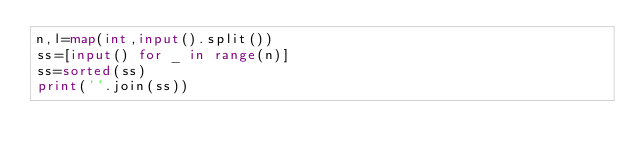Convert code to text. <code><loc_0><loc_0><loc_500><loc_500><_Python_>n,l=map(int,input().split())
ss=[input() for _ in range(n)]
ss=sorted(ss)
print(''.join(ss))
        </code> 